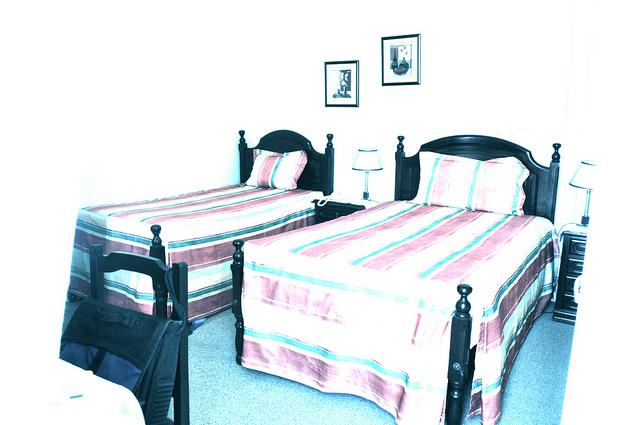How many people can sleep in this room? two 